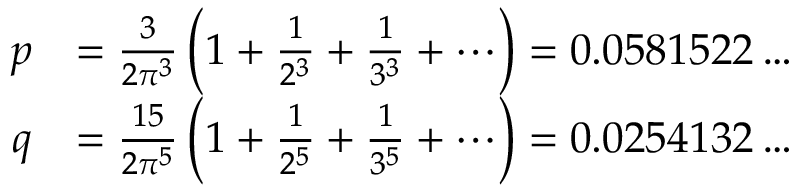Convert formula to latex. <formula><loc_0><loc_0><loc_500><loc_500>{ \begin{array} { r l } { p } & { = { \frac { 3 } { 2 \pi ^ { 3 } } } \left ( 1 + { \frac { 1 } { 2 ^ { 3 } } } + { \frac { 1 } { 3 ^ { 3 } } } + \cdots \right ) = 0 . 0 5 8 1 5 2 2 \dots } \\ { q } & { = { \frac { 1 5 } { 2 \pi ^ { 5 } } } \left ( 1 + { \frac { 1 } { 2 ^ { 5 } } } + { \frac { 1 } { 3 ^ { 5 } } } + \cdots \right ) = 0 . 0 2 5 4 1 3 2 \dots } \end{array} }</formula> 